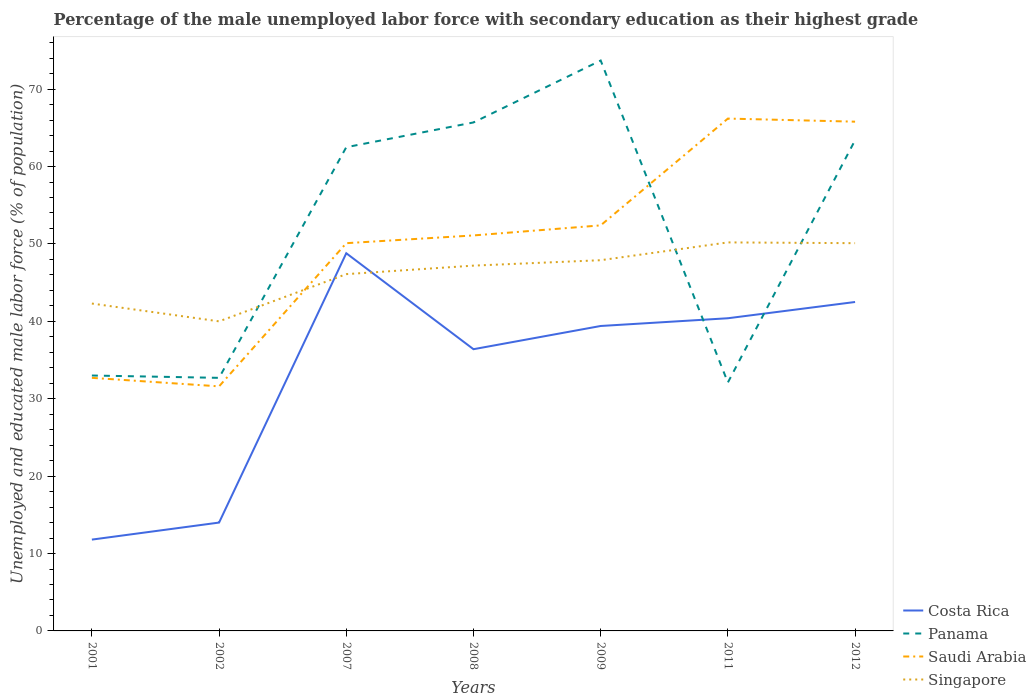How many different coloured lines are there?
Offer a very short reply. 4. Does the line corresponding to Singapore intersect with the line corresponding to Saudi Arabia?
Give a very brief answer. Yes. Across all years, what is the maximum percentage of the unemployed male labor force with secondary education in Panama?
Ensure brevity in your answer.  32.1. In which year was the percentage of the unemployed male labor force with secondary education in Panama maximum?
Ensure brevity in your answer.  2011. What is the total percentage of the unemployed male labor force with secondary education in Singapore in the graph?
Your answer should be compact. -7.9. What is the difference between the highest and the second highest percentage of the unemployed male labor force with secondary education in Costa Rica?
Your answer should be very brief. 37. How many years are there in the graph?
Your answer should be very brief. 7. Does the graph contain grids?
Offer a terse response. No. How are the legend labels stacked?
Offer a terse response. Vertical. What is the title of the graph?
Provide a succinct answer. Percentage of the male unemployed labor force with secondary education as their highest grade. Does "Middle East & North Africa (all income levels)" appear as one of the legend labels in the graph?
Your response must be concise. No. What is the label or title of the X-axis?
Offer a very short reply. Years. What is the label or title of the Y-axis?
Provide a succinct answer. Unemployed and educated male labor force (% of population). What is the Unemployed and educated male labor force (% of population) in Costa Rica in 2001?
Offer a very short reply. 11.8. What is the Unemployed and educated male labor force (% of population) of Saudi Arabia in 2001?
Provide a succinct answer. 32.7. What is the Unemployed and educated male labor force (% of population) of Singapore in 2001?
Your answer should be compact. 42.3. What is the Unemployed and educated male labor force (% of population) of Panama in 2002?
Your answer should be compact. 32.7. What is the Unemployed and educated male labor force (% of population) of Saudi Arabia in 2002?
Ensure brevity in your answer.  31.6. What is the Unemployed and educated male labor force (% of population) of Singapore in 2002?
Provide a succinct answer. 40. What is the Unemployed and educated male labor force (% of population) of Costa Rica in 2007?
Your answer should be very brief. 48.8. What is the Unemployed and educated male labor force (% of population) in Panama in 2007?
Give a very brief answer. 62.5. What is the Unemployed and educated male labor force (% of population) of Saudi Arabia in 2007?
Make the answer very short. 50.1. What is the Unemployed and educated male labor force (% of population) of Singapore in 2007?
Give a very brief answer. 46.1. What is the Unemployed and educated male labor force (% of population) of Costa Rica in 2008?
Your response must be concise. 36.4. What is the Unemployed and educated male labor force (% of population) in Panama in 2008?
Offer a terse response. 65.7. What is the Unemployed and educated male labor force (% of population) in Saudi Arabia in 2008?
Offer a terse response. 51.1. What is the Unemployed and educated male labor force (% of population) of Singapore in 2008?
Your answer should be compact. 47.2. What is the Unemployed and educated male labor force (% of population) in Costa Rica in 2009?
Offer a very short reply. 39.4. What is the Unemployed and educated male labor force (% of population) of Panama in 2009?
Provide a succinct answer. 73.7. What is the Unemployed and educated male labor force (% of population) in Saudi Arabia in 2009?
Your answer should be very brief. 52.4. What is the Unemployed and educated male labor force (% of population) of Singapore in 2009?
Give a very brief answer. 47.9. What is the Unemployed and educated male labor force (% of population) of Costa Rica in 2011?
Provide a succinct answer. 40.4. What is the Unemployed and educated male labor force (% of population) of Panama in 2011?
Provide a succinct answer. 32.1. What is the Unemployed and educated male labor force (% of population) in Saudi Arabia in 2011?
Offer a terse response. 66.2. What is the Unemployed and educated male labor force (% of population) of Singapore in 2011?
Make the answer very short. 50.2. What is the Unemployed and educated male labor force (% of population) of Costa Rica in 2012?
Keep it short and to the point. 42.5. What is the Unemployed and educated male labor force (% of population) in Panama in 2012?
Your answer should be compact. 63.4. What is the Unemployed and educated male labor force (% of population) of Saudi Arabia in 2012?
Offer a terse response. 65.8. What is the Unemployed and educated male labor force (% of population) of Singapore in 2012?
Provide a short and direct response. 50.1. Across all years, what is the maximum Unemployed and educated male labor force (% of population) in Costa Rica?
Offer a terse response. 48.8. Across all years, what is the maximum Unemployed and educated male labor force (% of population) in Panama?
Offer a very short reply. 73.7. Across all years, what is the maximum Unemployed and educated male labor force (% of population) in Saudi Arabia?
Your answer should be compact. 66.2. Across all years, what is the maximum Unemployed and educated male labor force (% of population) of Singapore?
Make the answer very short. 50.2. Across all years, what is the minimum Unemployed and educated male labor force (% of population) in Costa Rica?
Keep it short and to the point. 11.8. Across all years, what is the minimum Unemployed and educated male labor force (% of population) of Panama?
Provide a succinct answer. 32.1. Across all years, what is the minimum Unemployed and educated male labor force (% of population) of Saudi Arabia?
Your answer should be compact. 31.6. Across all years, what is the minimum Unemployed and educated male labor force (% of population) in Singapore?
Ensure brevity in your answer.  40. What is the total Unemployed and educated male labor force (% of population) in Costa Rica in the graph?
Offer a very short reply. 233.3. What is the total Unemployed and educated male labor force (% of population) in Panama in the graph?
Keep it short and to the point. 363.1. What is the total Unemployed and educated male labor force (% of population) in Saudi Arabia in the graph?
Provide a succinct answer. 349.9. What is the total Unemployed and educated male labor force (% of population) in Singapore in the graph?
Provide a succinct answer. 323.8. What is the difference between the Unemployed and educated male labor force (% of population) in Costa Rica in 2001 and that in 2002?
Keep it short and to the point. -2.2. What is the difference between the Unemployed and educated male labor force (% of population) in Costa Rica in 2001 and that in 2007?
Your answer should be compact. -37. What is the difference between the Unemployed and educated male labor force (% of population) of Panama in 2001 and that in 2007?
Give a very brief answer. -29.5. What is the difference between the Unemployed and educated male labor force (% of population) in Saudi Arabia in 2001 and that in 2007?
Give a very brief answer. -17.4. What is the difference between the Unemployed and educated male labor force (% of population) in Singapore in 2001 and that in 2007?
Give a very brief answer. -3.8. What is the difference between the Unemployed and educated male labor force (% of population) of Costa Rica in 2001 and that in 2008?
Keep it short and to the point. -24.6. What is the difference between the Unemployed and educated male labor force (% of population) in Panama in 2001 and that in 2008?
Your answer should be compact. -32.7. What is the difference between the Unemployed and educated male labor force (% of population) of Saudi Arabia in 2001 and that in 2008?
Your response must be concise. -18.4. What is the difference between the Unemployed and educated male labor force (% of population) of Singapore in 2001 and that in 2008?
Provide a short and direct response. -4.9. What is the difference between the Unemployed and educated male labor force (% of population) of Costa Rica in 2001 and that in 2009?
Keep it short and to the point. -27.6. What is the difference between the Unemployed and educated male labor force (% of population) in Panama in 2001 and that in 2009?
Provide a succinct answer. -40.7. What is the difference between the Unemployed and educated male labor force (% of population) of Saudi Arabia in 2001 and that in 2009?
Your answer should be compact. -19.7. What is the difference between the Unemployed and educated male labor force (% of population) in Singapore in 2001 and that in 2009?
Your answer should be compact. -5.6. What is the difference between the Unemployed and educated male labor force (% of population) of Costa Rica in 2001 and that in 2011?
Your answer should be compact. -28.6. What is the difference between the Unemployed and educated male labor force (% of population) of Saudi Arabia in 2001 and that in 2011?
Your answer should be very brief. -33.5. What is the difference between the Unemployed and educated male labor force (% of population) of Singapore in 2001 and that in 2011?
Offer a terse response. -7.9. What is the difference between the Unemployed and educated male labor force (% of population) of Costa Rica in 2001 and that in 2012?
Offer a very short reply. -30.7. What is the difference between the Unemployed and educated male labor force (% of population) of Panama in 2001 and that in 2012?
Your answer should be very brief. -30.4. What is the difference between the Unemployed and educated male labor force (% of population) of Saudi Arabia in 2001 and that in 2012?
Your response must be concise. -33.1. What is the difference between the Unemployed and educated male labor force (% of population) of Costa Rica in 2002 and that in 2007?
Your response must be concise. -34.8. What is the difference between the Unemployed and educated male labor force (% of population) in Panama in 2002 and that in 2007?
Make the answer very short. -29.8. What is the difference between the Unemployed and educated male labor force (% of population) in Saudi Arabia in 2002 and that in 2007?
Give a very brief answer. -18.5. What is the difference between the Unemployed and educated male labor force (% of population) of Singapore in 2002 and that in 2007?
Ensure brevity in your answer.  -6.1. What is the difference between the Unemployed and educated male labor force (% of population) of Costa Rica in 2002 and that in 2008?
Ensure brevity in your answer.  -22.4. What is the difference between the Unemployed and educated male labor force (% of population) of Panama in 2002 and that in 2008?
Your response must be concise. -33. What is the difference between the Unemployed and educated male labor force (% of population) of Saudi Arabia in 2002 and that in 2008?
Provide a succinct answer. -19.5. What is the difference between the Unemployed and educated male labor force (% of population) of Singapore in 2002 and that in 2008?
Ensure brevity in your answer.  -7.2. What is the difference between the Unemployed and educated male labor force (% of population) in Costa Rica in 2002 and that in 2009?
Keep it short and to the point. -25.4. What is the difference between the Unemployed and educated male labor force (% of population) of Panama in 2002 and that in 2009?
Offer a very short reply. -41. What is the difference between the Unemployed and educated male labor force (% of population) of Saudi Arabia in 2002 and that in 2009?
Offer a very short reply. -20.8. What is the difference between the Unemployed and educated male labor force (% of population) of Costa Rica in 2002 and that in 2011?
Make the answer very short. -26.4. What is the difference between the Unemployed and educated male labor force (% of population) in Saudi Arabia in 2002 and that in 2011?
Ensure brevity in your answer.  -34.6. What is the difference between the Unemployed and educated male labor force (% of population) of Singapore in 2002 and that in 2011?
Your answer should be very brief. -10.2. What is the difference between the Unemployed and educated male labor force (% of population) of Costa Rica in 2002 and that in 2012?
Provide a succinct answer. -28.5. What is the difference between the Unemployed and educated male labor force (% of population) in Panama in 2002 and that in 2012?
Offer a terse response. -30.7. What is the difference between the Unemployed and educated male labor force (% of population) in Saudi Arabia in 2002 and that in 2012?
Offer a very short reply. -34.2. What is the difference between the Unemployed and educated male labor force (% of population) in Singapore in 2002 and that in 2012?
Ensure brevity in your answer.  -10.1. What is the difference between the Unemployed and educated male labor force (% of population) in Costa Rica in 2007 and that in 2008?
Your response must be concise. 12.4. What is the difference between the Unemployed and educated male labor force (% of population) in Singapore in 2007 and that in 2009?
Your answer should be compact. -1.8. What is the difference between the Unemployed and educated male labor force (% of population) in Costa Rica in 2007 and that in 2011?
Offer a terse response. 8.4. What is the difference between the Unemployed and educated male labor force (% of population) in Panama in 2007 and that in 2011?
Provide a short and direct response. 30.4. What is the difference between the Unemployed and educated male labor force (% of population) in Saudi Arabia in 2007 and that in 2011?
Offer a terse response. -16.1. What is the difference between the Unemployed and educated male labor force (% of population) of Panama in 2007 and that in 2012?
Your response must be concise. -0.9. What is the difference between the Unemployed and educated male labor force (% of population) of Saudi Arabia in 2007 and that in 2012?
Provide a short and direct response. -15.7. What is the difference between the Unemployed and educated male labor force (% of population) of Singapore in 2007 and that in 2012?
Keep it short and to the point. -4. What is the difference between the Unemployed and educated male labor force (% of population) of Costa Rica in 2008 and that in 2009?
Your answer should be very brief. -3. What is the difference between the Unemployed and educated male labor force (% of population) in Saudi Arabia in 2008 and that in 2009?
Keep it short and to the point. -1.3. What is the difference between the Unemployed and educated male labor force (% of population) of Singapore in 2008 and that in 2009?
Provide a succinct answer. -0.7. What is the difference between the Unemployed and educated male labor force (% of population) of Panama in 2008 and that in 2011?
Provide a succinct answer. 33.6. What is the difference between the Unemployed and educated male labor force (% of population) of Saudi Arabia in 2008 and that in 2011?
Your answer should be very brief. -15.1. What is the difference between the Unemployed and educated male labor force (% of population) of Panama in 2008 and that in 2012?
Give a very brief answer. 2.3. What is the difference between the Unemployed and educated male labor force (% of population) in Saudi Arabia in 2008 and that in 2012?
Your response must be concise. -14.7. What is the difference between the Unemployed and educated male labor force (% of population) of Costa Rica in 2009 and that in 2011?
Give a very brief answer. -1. What is the difference between the Unemployed and educated male labor force (% of population) in Panama in 2009 and that in 2011?
Your answer should be very brief. 41.6. What is the difference between the Unemployed and educated male labor force (% of population) of Saudi Arabia in 2009 and that in 2011?
Provide a succinct answer. -13.8. What is the difference between the Unemployed and educated male labor force (% of population) in Costa Rica in 2009 and that in 2012?
Keep it short and to the point. -3.1. What is the difference between the Unemployed and educated male labor force (% of population) in Panama in 2009 and that in 2012?
Make the answer very short. 10.3. What is the difference between the Unemployed and educated male labor force (% of population) in Saudi Arabia in 2009 and that in 2012?
Offer a terse response. -13.4. What is the difference between the Unemployed and educated male labor force (% of population) of Panama in 2011 and that in 2012?
Your answer should be very brief. -31.3. What is the difference between the Unemployed and educated male labor force (% of population) in Costa Rica in 2001 and the Unemployed and educated male labor force (% of population) in Panama in 2002?
Give a very brief answer. -20.9. What is the difference between the Unemployed and educated male labor force (% of population) of Costa Rica in 2001 and the Unemployed and educated male labor force (% of population) of Saudi Arabia in 2002?
Provide a short and direct response. -19.8. What is the difference between the Unemployed and educated male labor force (% of population) in Costa Rica in 2001 and the Unemployed and educated male labor force (% of population) in Singapore in 2002?
Your answer should be very brief. -28.2. What is the difference between the Unemployed and educated male labor force (% of population) in Panama in 2001 and the Unemployed and educated male labor force (% of population) in Saudi Arabia in 2002?
Your answer should be compact. 1.4. What is the difference between the Unemployed and educated male labor force (% of population) in Panama in 2001 and the Unemployed and educated male labor force (% of population) in Singapore in 2002?
Provide a succinct answer. -7. What is the difference between the Unemployed and educated male labor force (% of population) in Costa Rica in 2001 and the Unemployed and educated male labor force (% of population) in Panama in 2007?
Keep it short and to the point. -50.7. What is the difference between the Unemployed and educated male labor force (% of population) in Costa Rica in 2001 and the Unemployed and educated male labor force (% of population) in Saudi Arabia in 2007?
Your response must be concise. -38.3. What is the difference between the Unemployed and educated male labor force (% of population) of Costa Rica in 2001 and the Unemployed and educated male labor force (% of population) of Singapore in 2007?
Ensure brevity in your answer.  -34.3. What is the difference between the Unemployed and educated male labor force (% of population) of Panama in 2001 and the Unemployed and educated male labor force (% of population) of Saudi Arabia in 2007?
Provide a short and direct response. -17.1. What is the difference between the Unemployed and educated male labor force (% of population) of Saudi Arabia in 2001 and the Unemployed and educated male labor force (% of population) of Singapore in 2007?
Your answer should be compact. -13.4. What is the difference between the Unemployed and educated male labor force (% of population) in Costa Rica in 2001 and the Unemployed and educated male labor force (% of population) in Panama in 2008?
Keep it short and to the point. -53.9. What is the difference between the Unemployed and educated male labor force (% of population) of Costa Rica in 2001 and the Unemployed and educated male labor force (% of population) of Saudi Arabia in 2008?
Make the answer very short. -39.3. What is the difference between the Unemployed and educated male labor force (% of population) in Costa Rica in 2001 and the Unemployed and educated male labor force (% of population) in Singapore in 2008?
Your answer should be compact. -35.4. What is the difference between the Unemployed and educated male labor force (% of population) of Panama in 2001 and the Unemployed and educated male labor force (% of population) of Saudi Arabia in 2008?
Provide a short and direct response. -18.1. What is the difference between the Unemployed and educated male labor force (% of population) in Costa Rica in 2001 and the Unemployed and educated male labor force (% of population) in Panama in 2009?
Your answer should be compact. -61.9. What is the difference between the Unemployed and educated male labor force (% of population) in Costa Rica in 2001 and the Unemployed and educated male labor force (% of population) in Saudi Arabia in 2009?
Your response must be concise. -40.6. What is the difference between the Unemployed and educated male labor force (% of population) in Costa Rica in 2001 and the Unemployed and educated male labor force (% of population) in Singapore in 2009?
Make the answer very short. -36.1. What is the difference between the Unemployed and educated male labor force (% of population) of Panama in 2001 and the Unemployed and educated male labor force (% of population) of Saudi Arabia in 2009?
Your answer should be very brief. -19.4. What is the difference between the Unemployed and educated male labor force (% of population) of Panama in 2001 and the Unemployed and educated male labor force (% of population) of Singapore in 2009?
Give a very brief answer. -14.9. What is the difference between the Unemployed and educated male labor force (% of population) of Saudi Arabia in 2001 and the Unemployed and educated male labor force (% of population) of Singapore in 2009?
Provide a short and direct response. -15.2. What is the difference between the Unemployed and educated male labor force (% of population) in Costa Rica in 2001 and the Unemployed and educated male labor force (% of population) in Panama in 2011?
Provide a short and direct response. -20.3. What is the difference between the Unemployed and educated male labor force (% of population) in Costa Rica in 2001 and the Unemployed and educated male labor force (% of population) in Saudi Arabia in 2011?
Keep it short and to the point. -54.4. What is the difference between the Unemployed and educated male labor force (% of population) of Costa Rica in 2001 and the Unemployed and educated male labor force (% of population) of Singapore in 2011?
Your response must be concise. -38.4. What is the difference between the Unemployed and educated male labor force (% of population) in Panama in 2001 and the Unemployed and educated male labor force (% of population) in Saudi Arabia in 2011?
Your answer should be very brief. -33.2. What is the difference between the Unemployed and educated male labor force (% of population) of Panama in 2001 and the Unemployed and educated male labor force (% of population) of Singapore in 2011?
Give a very brief answer. -17.2. What is the difference between the Unemployed and educated male labor force (% of population) of Saudi Arabia in 2001 and the Unemployed and educated male labor force (% of population) of Singapore in 2011?
Your response must be concise. -17.5. What is the difference between the Unemployed and educated male labor force (% of population) of Costa Rica in 2001 and the Unemployed and educated male labor force (% of population) of Panama in 2012?
Give a very brief answer. -51.6. What is the difference between the Unemployed and educated male labor force (% of population) of Costa Rica in 2001 and the Unemployed and educated male labor force (% of population) of Saudi Arabia in 2012?
Your response must be concise. -54. What is the difference between the Unemployed and educated male labor force (% of population) in Costa Rica in 2001 and the Unemployed and educated male labor force (% of population) in Singapore in 2012?
Your response must be concise. -38.3. What is the difference between the Unemployed and educated male labor force (% of population) in Panama in 2001 and the Unemployed and educated male labor force (% of population) in Saudi Arabia in 2012?
Provide a short and direct response. -32.8. What is the difference between the Unemployed and educated male labor force (% of population) of Panama in 2001 and the Unemployed and educated male labor force (% of population) of Singapore in 2012?
Offer a terse response. -17.1. What is the difference between the Unemployed and educated male labor force (% of population) of Saudi Arabia in 2001 and the Unemployed and educated male labor force (% of population) of Singapore in 2012?
Offer a very short reply. -17.4. What is the difference between the Unemployed and educated male labor force (% of population) in Costa Rica in 2002 and the Unemployed and educated male labor force (% of population) in Panama in 2007?
Provide a succinct answer. -48.5. What is the difference between the Unemployed and educated male labor force (% of population) of Costa Rica in 2002 and the Unemployed and educated male labor force (% of population) of Saudi Arabia in 2007?
Your answer should be very brief. -36.1. What is the difference between the Unemployed and educated male labor force (% of population) of Costa Rica in 2002 and the Unemployed and educated male labor force (% of population) of Singapore in 2007?
Keep it short and to the point. -32.1. What is the difference between the Unemployed and educated male labor force (% of population) in Panama in 2002 and the Unemployed and educated male labor force (% of population) in Saudi Arabia in 2007?
Offer a very short reply. -17.4. What is the difference between the Unemployed and educated male labor force (% of population) in Costa Rica in 2002 and the Unemployed and educated male labor force (% of population) in Panama in 2008?
Offer a very short reply. -51.7. What is the difference between the Unemployed and educated male labor force (% of population) in Costa Rica in 2002 and the Unemployed and educated male labor force (% of population) in Saudi Arabia in 2008?
Ensure brevity in your answer.  -37.1. What is the difference between the Unemployed and educated male labor force (% of population) in Costa Rica in 2002 and the Unemployed and educated male labor force (% of population) in Singapore in 2008?
Give a very brief answer. -33.2. What is the difference between the Unemployed and educated male labor force (% of population) in Panama in 2002 and the Unemployed and educated male labor force (% of population) in Saudi Arabia in 2008?
Make the answer very short. -18.4. What is the difference between the Unemployed and educated male labor force (% of population) in Panama in 2002 and the Unemployed and educated male labor force (% of population) in Singapore in 2008?
Keep it short and to the point. -14.5. What is the difference between the Unemployed and educated male labor force (% of population) of Saudi Arabia in 2002 and the Unemployed and educated male labor force (% of population) of Singapore in 2008?
Keep it short and to the point. -15.6. What is the difference between the Unemployed and educated male labor force (% of population) in Costa Rica in 2002 and the Unemployed and educated male labor force (% of population) in Panama in 2009?
Your response must be concise. -59.7. What is the difference between the Unemployed and educated male labor force (% of population) in Costa Rica in 2002 and the Unemployed and educated male labor force (% of population) in Saudi Arabia in 2009?
Make the answer very short. -38.4. What is the difference between the Unemployed and educated male labor force (% of population) of Costa Rica in 2002 and the Unemployed and educated male labor force (% of population) of Singapore in 2009?
Provide a succinct answer. -33.9. What is the difference between the Unemployed and educated male labor force (% of population) of Panama in 2002 and the Unemployed and educated male labor force (% of population) of Saudi Arabia in 2009?
Give a very brief answer. -19.7. What is the difference between the Unemployed and educated male labor force (% of population) in Panama in 2002 and the Unemployed and educated male labor force (% of population) in Singapore in 2009?
Provide a short and direct response. -15.2. What is the difference between the Unemployed and educated male labor force (% of population) in Saudi Arabia in 2002 and the Unemployed and educated male labor force (% of population) in Singapore in 2009?
Your answer should be very brief. -16.3. What is the difference between the Unemployed and educated male labor force (% of population) in Costa Rica in 2002 and the Unemployed and educated male labor force (% of population) in Panama in 2011?
Offer a very short reply. -18.1. What is the difference between the Unemployed and educated male labor force (% of population) in Costa Rica in 2002 and the Unemployed and educated male labor force (% of population) in Saudi Arabia in 2011?
Your answer should be compact. -52.2. What is the difference between the Unemployed and educated male labor force (% of population) of Costa Rica in 2002 and the Unemployed and educated male labor force (% of population) of Singapore in 2011?
Your response must be concise. -36.2. What is the difference between the Unemployed and educated male labor force (% of population) in Panama in 2002 and the Unemployed and educated male labor force (% of population) in Saudi Arabia in 2011?
Offer a very short reply. -33.5. What is the difference between the Unemployed and educated male labor force (% of population) of Panama in 2002 and the Unemployed and educated male labor force (% of population) of Singapore in 2011?
Your answer should be very brief. -17.5. What is the difference between the Unemployed and educated male labor force (% of population) of Saudi Arabia in 2002 and the Unemployed and educated male labor force (% of population) of Singapore in 2011?
Give a very brief answer. -18.6. What is the difference between the Unemployed and educated male labor force (% of population) in Costa Rica in 2002 and the Unemployed and educated male labor force (% of population) in Panama in 2012?
Make the answer very short. -49.4. What is the difference between the Unemployed and educated male labor force (% of population) in Costa Rica in 2002 and the Unemployed and educated male labor force (% of population) in Saudi Arabia in 2012?
Your answer should be very brief. -51.8. What is the difference between the Unemployed and educated male labor force (% of population) of Costa Rica in 2002 and the Unemployed and educated male labor force (% of population) of Singapore in 2012?
Your answer should be very brief. -36.1. What is the difference between the Unemployed and educated male labor force (% of population) of Panama in 2002 and the Unemployed and educated male labor force (% of population) of Saudi Arabia in 2012?
Make the answer very short. -33.1. What is the difference between the Unemployed and educated male labor force (% of population) of Panama in 2002 and the Unemployed and educated male labor force (% of population) of Singapore in 2012?
Your response must be concise. -17.4. What is the difference between the Unemployed and educated male labor force (% of population) of Saudi Arabia in 2002 and the Unemployed and educated male labor force (% of population) of Singapore in 2012?
Keep it short and to the point. -18.5. What is the difference between the Unemployed and educated male labor force (% of population) of Costa Rica in 2007 and the Unemployed and educated male labor force (% of population) of Panama in 2008?
Provide a short and direct response. -16.9. What is the difference between the Unemployed and educated male labor force (% of population) in Panama in 2007 and the Unemployed and educated male labor force (% of population) in Saudi Arabia in 2008?
Your answer should be very brief. 11.4. What is the difference between the Unemployed and educated male labor force (% of population) of Costa Rica in 2007 and the Unemployed and educated male labor force (% of population) of Panama in 2009?
Your answer should be compact. -24.9. What is the difference between the Unemployed and educated male labor force (% of population) in Costa Rica in 2007 and the Unemployed and educated male labor force (% of population) in Singapore in 2009?
Give a very brief answer. 0.9. What is the difference between the Unemployed and educated male labor force (% of population) in Panama in 2007 and the Unemployed and educated male labor force (% of population) in Singapore in 2009?
Offer a very short reply. 14.6. What is the difference between the Unemployed and educated male labor force (% of population) in Costa Rica in 2007 and the Unemployed and educated male labor force (% of population) in Saudi Arabia in 2011?
Make the answer very short. -17.4. What is the difference between the Unemployed and educated male labor force (% of population) of Costa Rica in 2007 and the Unemployed and educated male labor force (% of population) of Panama in 2012?
Keep it short and to the point. -14.6. What is the difference between the Unemployed and educated male labor force (% of population) in Costa Rica in 2007 and the Unemployed and educated male labor force (% of population) in Saudi Arabia in 2012?
Your answer should be very brief. -17. What is the difference between the Unemployed and educated male labor force (% of population) in Costa Rica in 2007 and the Unemployed and educated male labor force (% of population) in Singapore in 2012?
Provide a short and direct response. -1.3. What is the difference between the Unemployed and educated male labor force (% of population) in Costa Rica in 2008 and the Unemployed and educated male labor force (% of population) in Panama in 2009?
Offer a very short reply. -37.3. What is the difference between the Unemployed and educated male labor force (% of population) in Costa Rica in 2008 and the Unemployed and educated male labor force (% of population) in Saudi Arabia in 2009?
Your response must be concise. -16. What is the difference between the Unemployed and educated male labor force (% of population) of Panama in 2008 and the Unemployed and educated male labor force (% of population) of Singapore in 2009?
Your answer should be compact. 17.8. What is the difference between the Unemployed and educated male labor force (% of population) of Costa Rica in 2008 and the Unemployed and educated male labor force (% of population) of Saudi Arabia in 2011?
Offer a very short reply. -29.8. What is the difference between the Unemployed and educated male labor force (% of population) in Costa Rica in 2008 and the Unemployed and educated male labor force (% of population) in Singapore in 2011?
Your answer should be very brief. -13.8. What is the difference between the Unemployed and educated male labor force (% of population) in Panama in 2008 and the Unemployed and educated male labor force (% of population) in Saudi Arabia in 2011?
Keep it short and to the point. -0.5. What is the difference between the Unemployed and educated male labor force (% of population) in Panama in 2008 and the Unemployed and educated male labor force (% of population) in Singapore in 2011?
Offer a very short reply. 15.5. What is the difference between the Unemployed and educated male labor force (% of population) of Costa Rica in 2008 and the Unemployed and educated male labor force (% of population) of Panama in 2012?
Offer a terse response. -27. What is the difference between the Unemployed and educated male labor force (% of population) in Costa Rica in 2008 and the Unemployed and educated male labor force (% of population) in Saudi Arabia in 2012?
Your answer should be compact. -29.4. What is the difference between the Unemployed and educated male labor force (% of population) of Costa Rica in 2008 and the Unemployed and educated male labor force (% of population) of Singapore in 2012?
Give a very brief answer. -13.7. What is the difference between the Unemployed and educated male labor force (% of population) in Saudi Arabia in 2008 and the Unemployed and educated male labor force (% of population) in Singapore in 2012?
Keep it short and to the point. 1. What is the difference between the Unemployed and educated male labor force (% of population) of Costa Rica in 2009 and the Unemployed and educated male labor force (% of population) of Saudi Arabia in 2011?
Provide a short and direct response. -26.8. What is the difference between the Unemployed and educated male labor force (% of population) in Panama in 2009 and the Unemployed and educated male labor force (% of population) in Singapore in 2011?
Make the answer very short. 23.5. What is the difference between the Unemployed and educated male labor force (% of population) in Saudi Arabia in 2009 and the Unemployed and educated male labor force (% of population) in Singapore in 2011?
Ensure brevity in your answer.  2.2. What is the difference between the Unemployed and educated male labor force (% of population) in Costa Rica in 2009 and the Unemployed and educated male labor force (% of population) in Saudi Arabia in 2012?
Offer a very short reply. -26.4. What is the difference between the Unemployed and educated male labor force (% of population) of Costa Rica in 2009 and the Unemployed and educated male labor force (% of population) of Singapore in 2012?
Your answer should be very brief. -10.7. What is the difference between the Unemployed and educated male labor force (% of population) of Panama in 2009 and the Unemployed and educated male labor force (% of population) of Saudi Arabia in 2012?
Offer a very short reply. 7.9. What is the difference between the Unemployed and educated male labor force (% of population) in Panama in 2009 and the Unemployed and educated male labor force (% of population) in Singapore in 2012?
Offer a terse response. 23.6. What is the difference between the Unemployed and educated male labor force (% of population) in Costa Rica in 2011 and the Unemployed and educated male labor force (% of population) in Saudi Arabia in 2012?
Your response must be concise. -25.4. What is the difference between the Unemployed and educated male labor force (% of population) in Panama in 2011 and the Unemployed and educated male labor force (% of population) in Saudi Arabia in 2012?
Provide a short and direct response. -33.7. What is the difference between the Unemployed and educated male labor force (% of population) in Saudi Arabia in 2011 and the Unemployed and educated male labor force (% of population) in Singapore in 2012?
Offer a terse response. 16.1. What is the average Unemployed and educated male labor force (% of population) in Costa Rica per year?
Keep it short and to the point. 33.33. What is the average Unemployed and educated male labor force (% of population) in Panama per year?
Offer a very short reply. 51.87. What is the average Unemployed and educated male labor force (% of population) in Saudi Arabia per year?
Offer a terse response. 49.99. What is the average Unemployed and educated male labor force (% of population) of Singapore per year?
Ensure brevity in your answer.  46.26. In the year 2001, what is the difference between the Unemployed and educated male labor force (% of population) in Costa Rica and Unemployed and educated male labor force (% of population) in Panama?
Your answer should be very brief. -21.2. In the year 2001, what is the difference between the Unemployed and educated male labor force (% of population) of Costa Rica and Unemployed and educated male labor force (% of population) of Saudi Arabia?
Your answer should be very brief. -20.9. In the year 2001, what is the difference between the Unemployed and educated male labor force (% of population) of Costa Rica and Unemployed and educated male labor force (% of population) of Singapore?
Ensure brevity in your answer.  -30.5. In the year 2001, what is the difference between the Unemployed and educated male labor force (% of population) in Panama and Unemployed and educated male labor force (% of population) in Singapore?
Make the answer very short. -9.3. In the year 2001, what is the difference between the Unemployed and educated male labor force (% of population) of Saudi Arabia and Unemployed and educated male labor force (% of population) of Singapore?
Ensure brevity in your answer.  -9.6. In the year 2002, what is the difference between the Unemployed and educated male labor force (% of population) of Costa Rica and Unemployed and educated male labor force (% of population) of Panama?
Your answer should be compact. -18.7. In the year 2002, what is the difference between the Unemployed and educated male labor force (% of population) in Costa Rica and Unemployed and educated male labor force (% of population) in Saudi Arabia?
Ensure brevity in your answer.  -17.6. In the year 2002, what is the difference between the Unemployed and educated male labor force (% of population) of Panama and Unemployed and educated male labor force (% of population) of Saudi Arabia?
Provide a succinct answer. 1.1. In the year 2007, what is the difference between the Unemployed and educated male labor force (% of population) in Costa Rica and Unemployed and educated male labor force (% of population) in Panama?
Provide a short and direct response. -13.7. In the year 2007, what is the difference between the Unemployed and educated male labor force (% of population) of Costa Rica and Unemployed and educated male labor force (% of population) of Singapore?
Make the answer very short. 2.7. In the year 2007, what is the difference between the Unemployed and educated male labor force (% of population) of Panama and Unemployed and educated male labor force (% of population) of Singapore?
Make the answer very short. 16.4. In the year 2007, what is the difference between the Unemployed and educated male labor force (% of population) in Saudi Arabia and Unemployed and educated male labor force (% of population) in Singapore?
Your answer should be very brief. 4. In the year 2008, what is the difference between the Unemployed and educated male labor force (% of population) in Costa Rica and Unemployed and educated male labor force (% of population) in Panama?
Make the answer very short. -29.3. In the year 2008, what is the difference between the Unemployed and educated male labor force (% of population) in Costa Rica and Unemployed and educated male labor force (% of population) in Saudi Arabia?
Offer a terse response. -14.7. In the year 2008, what is the difference between the Unemployed and educated male labor force (% of population) in Panama and Unemployed and educated male labor force (% of population) in Saudi Arabia?
Make the answer very short. 14.6. In the year 2008, what is the difference between the Unemployed and educated male labor force (% of population) in Panama and Unemployed and educated male labor force (% of population) in Singapore?
Provide a succinct answer. 18.5. In the year 2008, what is the difference between the Unemployed and educated male labor force (% of population) in Saudi Arabia and Unemployed and educated male labor force (% of population) in Singapore?
Your response must be concise. 3.9. In the year 2009, what is the difference between the Unemployed and educated male labor force (% of population) of Costa Rica and Unemployed and educated male labor force (% of population) of Panama?
Offer a very short reply. -34.3. In the year 2009, what is the difference between the Unemployed and educated male labor force (% of population) in Panama and Unemployed and educated male labor force (% of population) in Saudi Arabia?
Your response must be concise. 21.3. In the year 2009, what is the difference between the Unemployed and educated male labor force (% of population) of Panama and Unemployed and educated male labor force (% of population) of Singapore?
Provide a short and direct response. 25.8. In the year 2011, what is the difference between the Unemployed and educated male labor force (% of population) in Costa Rica and Unemployed and educated male labor force (% of population) in Saudi Arabia?
Your response must be concise. -25.8. In the year 2011, what is the difference between the Unemployed and educated male labor force (% of population) of Panama and Unemployed and educated male labor force (% of population) of Saudi Arabia?
Your answer should be compact. -34.1. In the year 2011, what is the difference between the Unemployed and educated male labor force (% of population) of Panama and Unemployed and educated male labor force (% of population) of Singapore?
Offer a very short reply. -18.1. In the year 2011, what is the difference between the Unemployed and educated male labor force (% of population) in Saudi Arabia and Unemployed and educated male labor force (% of population) in Singapore?
Your answer should be very brief. 16. In the year 2012, what is the difference between the Unemployed and educated male labor force (% of population) of Costa Rica and Unemployed and educated male labor force (% of population) of Panama?
Ensure brevity in your answer.  -20.9. In the year 2012, what is the difference between the Unemployed and educated male labor force (% of population) of Costa Rica and Unemployed and educated male labor force (% of population) of Saudi Arabia?
Provide a short and direct response. -23.3. In the year 2012, what is the difference between the Unemployed and educated male labor force (% of population) of Costa Rica and Unemployed and educated male labor force (% of population) of Singapore?
Ensure brevity in your answer.  -7.6. In the year 2012, what is the difference between the Unemployed and educated male labor force (% of population) of Saudi Arabia and Unemployed and educated male labor force (% of population) of Singapore?
Keep it short and to the point. 15.7. What is the ratio of the Unemployed and educated male labor force (% of population) in Costa Rica in 2001 to that in 2002?
Offer a terse response. 0.84. What is the ratio of the Unemployed and educated male labor force (% of population) in Panama in 2001 to that in 2002?
Ensure brevity in your answer.  1.01. What is the ratio of the Unemployed and educated male labor force (% of population) of Saudi Arabia in 2001 to that in 2002?
Provide a short and direct response. 1.03. What is the ratio of the Unemployed and educated male labor force (% of population) of Singapore in 2001 to that in 2002?
Ensure brevity in your answer.  1.06. What is the ratio of the Unemployed and educated male labor force (% of population) in Costa Rica in 2001 to that in 2007?
Your response must be concise. 0.24. What is the ratio of the Unemployed and educated male labor force (% of population) in Panama in 2001 to that in 2007?
Provide a succinct answer. 0.53. What is the ratio of the Unemployed and educated male labor force (% of population) in Saudi Arabia in 2001 to that in 2007?
Your answer should be compact. 0.65. What is the ratio of the Unemployed and educated male labor force (% of population) of Singapore in 2001 to that in 2007?
Make the answer very short. 0.92. What is the ratio of the Unemployed and educated male labor force (% of population) of Costa Rica in 2001 to that in 2008?
Offer a very short reply. 0.32. What is the ratio of the Unemployed and educated male labor force (% of population) of Panama in 2001 to that in 2008?
Offer a very short reply. 0.5. What is the ratio of the Unemployed and educated male labor force (% of population) in Saudi Arabia in 2001 to that in 2008?
Offer a terse response. 0.64. What is the ratio of the Unemployed and educated male labor force (% of population) in Singapore in 2001 to that in 2008?
Ensure brevity in your answer.  0.9. What is the ratio of the Unemployed and educated male labor force (% of population) of Costa Rica in 2001 to that in 2009?
Your answer should be compact. 0.3. What is the ratio of the Unemployed and educated male labor force (% of population) of Panama in 2001 to that in 2009?
Your answer should be very brief. 0.45. What is the ratio of the Unemployed and educated male labor force (% of population) of Saudi Arabia in 2001 to that in 2009?
Provide a succinct answer. 0.62. What is the ratio of the Unemployed and educated male labor force (% of population) in Singapore in 2001 to that in 2009?
Offer a terse response. 0.88. What is the ratio of the Unemployed and educated male labor force (% of population) of Costa Rica in 2001 to that in 2011?
Provide a succinct answer. 0.29. What is the ratio of the Unemployed and educated male labor force (% of population) in Panama in 2001 to that in 2011?
Give a very brief answer. 1.03. What is the ratio of the Unemployed and educated male labor force (% of population) in Saudi Arabia in 2001 to that in 2011?
Give a very brief answer. 0.49. What is the ratio of the Unemployed and educated male labor force (% of population) in Singapore in 2001 to that in 2011?
Give a very brief answer. 0.84. What is the ratio of the Unemployed and educated male labor force (% of population) in Costa Rica in 2001 to that in 2012?
Provide a short and direct response. 0.28. What is the ratio of the Unemployed and educated male labor force (% of population) in Panama in 2001 to that in 2012?
Make the answer very short. 0.52. What is the ratio of the Unemployed and educated male labor force (% of population) in Saudi Arabia in 2001 to that in 2012?
Your response must be concise. 0.5. What is the ratio of the Unemployed and educated male labor force (% of population) in Singapore in 2001 to that in 2012?
Give a very brief answer. 0.84. What is the ratio of the Unemployed and educated male labor force (% of population) of Costa Rica in 2002 to that in 2007?
Your response must be concise. 0.29. What is the ratio of the Unemployed and educated male labor force (% of population) of Panama in 2002 to that in 2007?
Provide a short and direct response. 0.52. What is the ratio of the Unemployed and educated male labor force (% of population) of Saudi Arabia in 2002 to that in 2007?
Your answer should be very brief. 0.63. What is the ratio of the Unemployed and educated male labor force (% of population) of Singapore in 2002 to that in 2007?
Make the answer very short. 0.87. What is the ratio of the Unemployed and educated male labor force (% of population) in Costa Rica in 2002 to that in 2008?
Keep it short and to the point. 0.38. What is the ratio of the Unemployed and educated male labor force (% of population) of Panama in 2002 to that in 2008?
Keep it short and to the point. 0.5. What is the ratio of the Unemployed and educated male labor force (% of population) of Saudi Arabia in 2002 to that in 2008?
Make the answer very short. 0.62. What is the ratio of the Unemployed and educated male labor force (% of population) in Singapore in 2002 to that in 2008?
Ensure brevity in your answer.  0.85. What is the ratio of the Unemployed and educated male labor force (% of population) in Costa Rica in 2002 to that in 2009?
Offer a terse response. 0.36. What is the ratio of the Unemployed and educated male labor force (% of population) in Panama in 2002 to that in 2009?
Keep it short and to the point. 0.44. What is the ratio of the Unemployed and educated male labor force (% of population) in Saudi Arabia in 2002 to that in 2009?
Provide a short and direct response. 0.6. What is the ratio of the Unemployed and educated male labor force (% of population) in Singapore in 2002 to that in 2009?
Keep it short and to the point. 0.84. What is the ratio of the Unemployed and educated male labor force (% of population) in Costa Rica in 2002 to that in 2011?
Offer a terse response. 0.35. What is the ratio of the Unemployed and educated male labor force (% of population) of Panama in 2002 to that in 2011?
Offer a very short reply. 1.02. What is the ratio of the Unemployed and educated male labor force (% of population) of Saudi Arabia in 2002 to that in 2011?
Offer a very short reply. 0.48. What is the ratio of the Unemployed and educated male labor force (% of population) in Singapore in 2002 to that in 2011?
Give a very brief answer. 0.8. What is the ratio of the Unemployed and educated male labor force (% of population) in Costa Rica in 2002 to that in 2012?
Your answer should be very brief. 0.33. What is the ratio of the Unemployed and educated male labor force (% of population) of Panama in 2002 to that in 2012?
Ensure brevity in your answer.  0.52. What is the ratio of the Unemployed and educated male labor force (% of population) in Saudi Arabia in 2002 to that in 2012?
Your response must be concise. 0.48. What is the ratio of the Unemployed and educated male labor force (% of population) in Singapore in 2002 to that in 2012?
Your answer should be very brief. 0.8. What is the ratio of the Unemployed and educated male labor force (% of population) in Costa Rica in 2007 to that in 2008?
Provide a short and direct response. 1.34. What is the ratio of the Unemployed and educated male labor force (% of population) in Panama in 2007 to that in 2008?
Ensure brevity in your answer.  0.95. What is the ratio of the Unemployed and educated male labor force (% of population) in Saudi Arabia in 2007 to that in 2008?
Make the answer very short. 0.98. What is the ratio of the Unemployed and educated male labor force (% of population) in Singapore in 2007 to that in 2008?
Your answer should be compact. 0.98. What is the ratio of the Unemployed and educated male labor force (% of population) in Costa Rica in 2007 to that in 2009?
Give a very brief answer. 1.24. What is the ratio of the Unemployed and educated male labor force (% of population) of Panama in 2007 to that in 2009?
Your answer should be very brief. 0.85. What is the ratio of the Unemployed and educated male labor force (% of population) in Saudi Arabia in 2007 to that in 2009?
Your response must be concise. 0.96. What is the ratio of the Unemployed and educated male labor force (% of population) of Singapore in 2007 to that in 2009?
Keep it short and to the point. 0.96. What is the ratio of the Unemployed and educated male labor force (% of population) in Costa Rica in 2007 to that in 2011?
Your response must be concise. 1.21. What is the ratio of the Unemployed and educated male labor force (% of population) in Panama in 2007 to that in 2011?
Your answer should be very brief. 1.95. What is the ratio of the Unemployed and educated male labor force (% of population) of Saudi Arabia in 2007 to that in 2011?
Keep it short and to the point. 0.76. What is the ratio of the Unemployed and educated male labor force (% of population) in Singapore in 2007 to that in 2011?
Your answer should be compact. 0.92. What is the ratio of the Unemployed and educated male labor force (% of population) of Costa Rica in 2007 to that in 2012?
Ensure brevity in your answer.  1.15. What is the ratio of the Unemployed and educated male labor force (% of population) in Panama in 2007 to that in 2012?
Keep it short and to the point. 0.99. What is the ratio of the Unemployed and educated male labor force (% of population) in Saudi Arabia in 2007 to that in 2012?
Provide a short and direct response. 0.76. What is the ratio of the Unemployed and educated male labor force (% of population) of Singapore in 2007 to that in 2012?
Give a very brief answer. 0.92. What is the ratio of the Unemployed and educated male labor force (% of population) in Costa Rica in 2008 to that in 2009?
Your response must be concise. 0.92. What is the ratio of the Unemployed and educated male labor force (% of population) in Panama in 2008 to that in 2009?
Your answer should be compact. 0.89. What is the ratio of the Unemployed and educated male labor force (% of population) in Saudi Arabia in 2008 to that in 2009?
Offer a terse response. 0.98. What is the ratio of the Unemployed and educated male labor force (% of population) of Singapore in 2008 to that in 2009?
Your answer should be very brief. 0.99. What is the ratio of the Unemployed and educated male labor force (% of population) of Costa Rica in 2008 to that in 2011?
Make the answer very short. 0.9. What is the ratio of the Unemployed and educated male labor force (% of population) in Panama in 2008 to that in 2011?
Make the answer very short. 2.05. What is the ratio of the Unemployed and educated male labor force (% of population) of Saudi Arabia in 2008 to that in 2011?
Offer a very short reply. 0.77. What is the ratio of the Unemployed and educated male labor force (% of population) in Singapore in 2008 to that in 2011?
Provide a succinct answer. 0.94. What is the ratio of the Unemployed and educated male labor force (% of population) in Costa Rica in 2008 to that in 2012?
Offer a very short reply. 0.86. What is the ratio of the Unemployed and educated male labor force (% of population) of Panama in 2008 to that in 2012?
Offer a terse response. 1.04. What is the ratio of the Unemployed and educated male labor force (% of population) of Saudi Arabia in 2008 to that in 2012?
Provide a short and direct response. 0.78. What is the ratio of the Unemployed and educated male labor force (% of population) of Singapore in 2008 to that in 2012?
Provide a succinct answer. 0.94. What is the ratio of the Unemployed and educated male labor force (% of population) in Costa Rica in 2009 to that in 2011?
Offer a very short reply. 0.98. What is the ratio of the Unemployed and educated male labor force (% of population) of Panama in 2009 to that in 2011?
Ensure brevity in your answer.  2.3. What is the ratio of the Unemployed and educated male labor force (% of population) of Saudi Arabia in 2009 to that in 2011?
Keep it short and to the point. 0.79. What is the ratio of the Unemployed and educated male labor force (% of population) of Singapore in 2009 to that in 2011?
Your answer should be compact. 0.95. What is the ratio of the Unemployed and educated male labor force (% of population) of Costa Rica in 2009 to that in 2012?
Make the answer very short. 0.93. What is the ratio of the Unemployed and educated male labor force (% of population) in Panama in 2009 to that in 2012?
Give a very brief answer. 1.16. What is the ratio of the Unemployed and educated male labor force (% of population) in Saudi Arabia in 2009 to that in 2012?
Provide a succinct answer. 0.8. What is the ratio of the Unemployed and educated male labor force (% of population) of Singapore in 2009 to that in 2012?
Give a very brief answer. 0.96. What is the ratio of the Unemployed and educated male labor force (% of population) in Costa Rica in 2011 to that in 2012?
Your answer should be compact. 0.95. What is the ratio of the Unemployed and educated male labor force (% of population) of Panama in 2011 to that in 2012?
Your answer should be compact. 0.51. What is the ratio of the Unemployed and educated male labor force (% of population) in Saudi Arabia in 2011 to that in 2012?
Give a very brief answer. 1.01. What is the ratio of the Unemployed and educated male labor force (% of population) of Singapore in 2011 to that in 2012?
Ensure brevity in your answer.  1. What is the difference between the highest and the second highest Unemployed and educated male labor force (% of population) of Costa Rica?
Offer a very short reply. 6.3. What is the difference between the highest and the second highest Unemployed and educated male labor force (% of population) of Panama?
Make the answer very short. 8. What is the difference between the highest and the second highest Unemployed and educated male labor force (% of population) of Singapore?
Give a very brief answer. 0.1. What is the difference between the highest and the lowest Unemployed and educated male labor force (% of population) in Panama?
Offer a terse response. 41.6. What is the difference between the highest and the lowest Unemployed and educated male labor force (% of population) of Saudi Arabia?
Offer a very short reply. 34.6. 